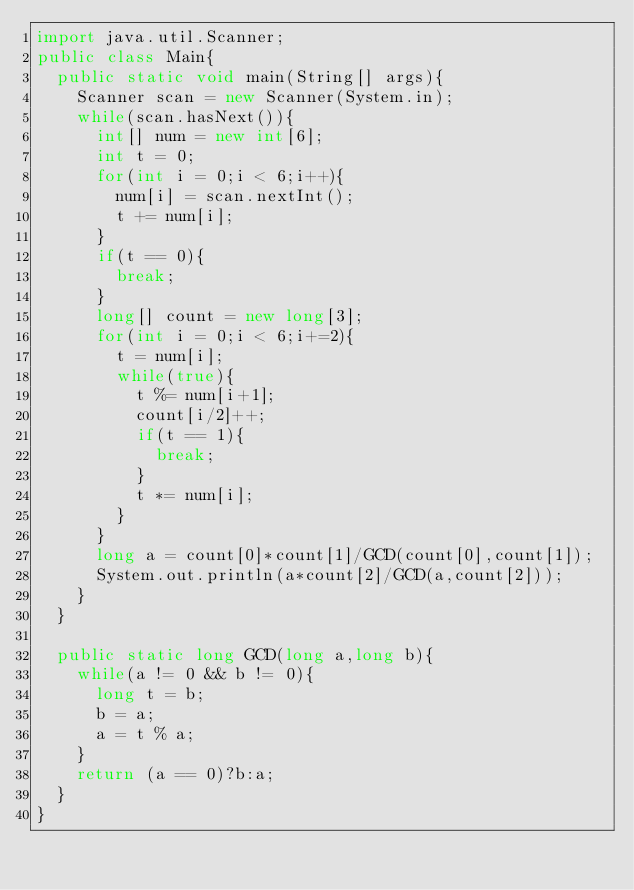<code> <loc_0><loc_0><loc_500><loc_500><_Java_>import java.util.Scanner;
public class Main{
	public static void main(String[] args){
		Scanner scan = new Scanner(System.in);
		while(scan.hasNext()){
			int[] num = new int[6];
			int t = 0;
			for(int i = 0;i < 6;i++){
				num[i] = scan.nextInt();
				t += num[i];
			}
			if(t == 0){
				break;
			}
			long[] count = new long[3];
			for(int i = 0;i < 6;i+=2){
				t = num[i];
				while(true){
					t %= num[i+1];
					count[i/2]++;
					if(t == 1){
						break;
					}
					t *= num[i];
				}
			}
			long a = count[0]*count[1]/GCD(count[0],count[1]);
			System.out.println(a*count[2]/GCD(a,count[2]));
		}
	}
	
	public static long GCD(long a,long b){
		while(a != 0 && b != 0){
			long t = b;
			b = a;
			a = t % a;
		}
		return (a == 0)?b:a;
	}
}</code> 